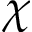<formula> <loc_0><loc_0><loc_500><loc_500>\chi</formula> 